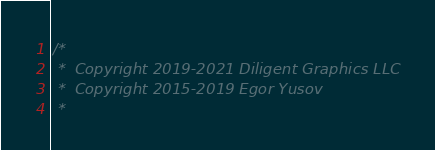<code> <loc_0><loc_0><loc_500><loc_500><_C++_>/*
 *  Copyright 2019-2021 Diligent Graphics LLC
 *  Copyright 2015-2019 Egor Yusov
 *  </code> 